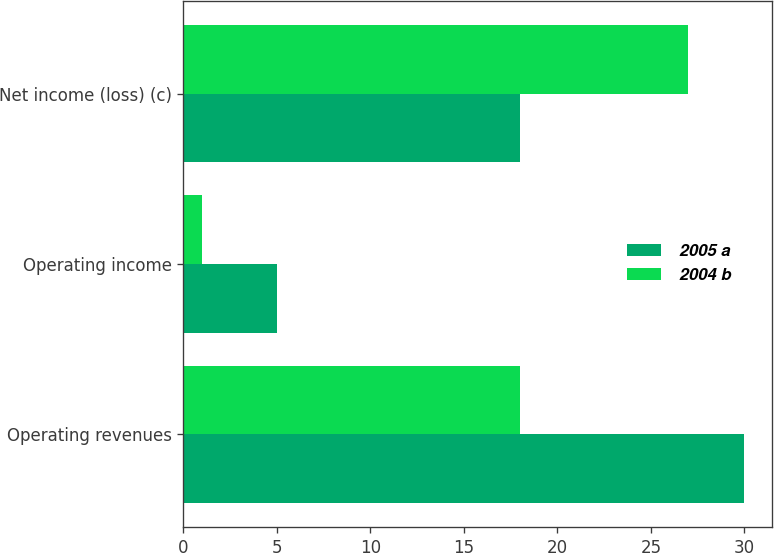Convert chart. <chart><loc_0><loc_0><loc_500><loc_500><stacked_bar_chart><ecel><fcel>Operating revenues<fcel>Operating income<fcel>Net income (loss) (c)<nl><fcel>2005 a<fcel>30<fcel>5<fcel>18<nl><fcel>2004 b<fcel>18<fcel>1<fcel>27<nl></chart> 